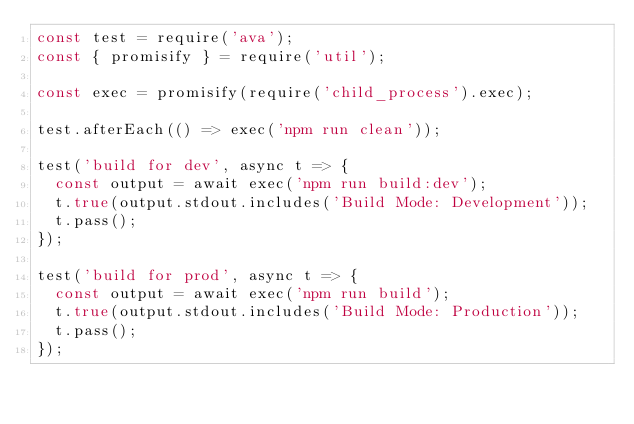Convert code to text. <code><loc_0><loc_0><loc_500><loc_500><_JavaScript_>const test = require('ava');
const { promisify } = require('util');

const exec = promisify(require('child_process').exec);

test.afterEach(() => exec('npm run clean'));

test('build for dev', async t => {
  const output = await exec('npm run build:dev');
  t.true(output.stdout.includes('Build Mode: Development'));
  t.pass();
});

test('build for prod', async t => {
  const output = await exec('npm run build');
  t.true(output.stdout.includes('Build Mode: Production'));
  t.pass();
});
</code> 